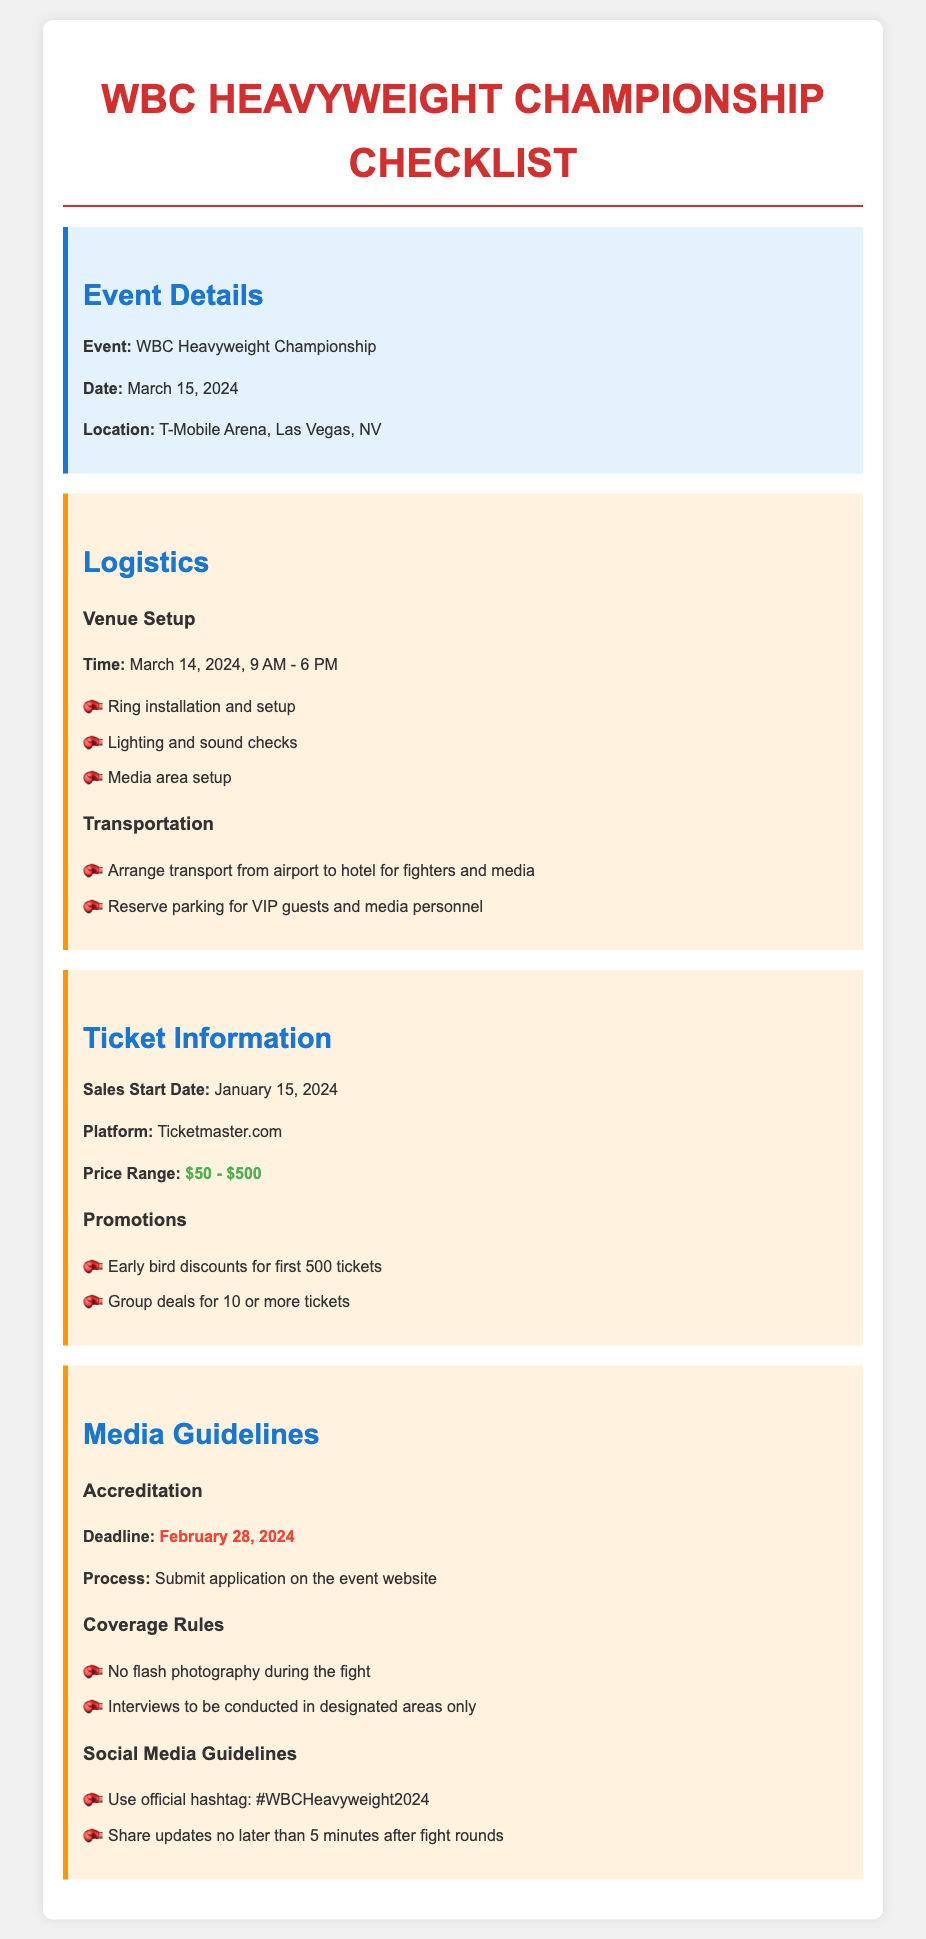What is the date of the event? The event takes place on March 15, 2024, as stated in the event details section.
Answer: March 15, 2024 Where is the event held? The location of the event is mentioned as T-Mobile Arena, Las Vegas, NV.
Answer: T-Mobile Arena, Las Vegas, NV What is the ticket sales start date? The document specifies January 15, 2024, as the date when ticket sales begin.
Answer: January 15, 2024 What is the price range for tickets? The price range provided is from $50 to $500, detailed in the ticket information section.
Answer: $50 - $500 What is the deadline for media accreditation? The document states that the deadline for media accreditation is February 28, 2024.
Answer: February 28, 2024 What are the promotional offers for tickets? The promotions indicated include early bird discounts for the first 500 tickets and group deals for 10 or more tickets.
Answer: Early bird discounts and group deals What is one rule regarding media coverage? The guidelines mention that no flash photography is allowed during the fight as a rule for media coverage.
Answer: No flash photography Which platform will tickets be sold on? Ticketmaster.com is the specified platform for ticket sales, as stated in the ticket information section.
Answer: Ticketmaster.com What should be used as the official hashtag? The document notes that the official hashtag to be used is #WBCHeavyweight2024.
Answer: #WBCHeavyweight2024 